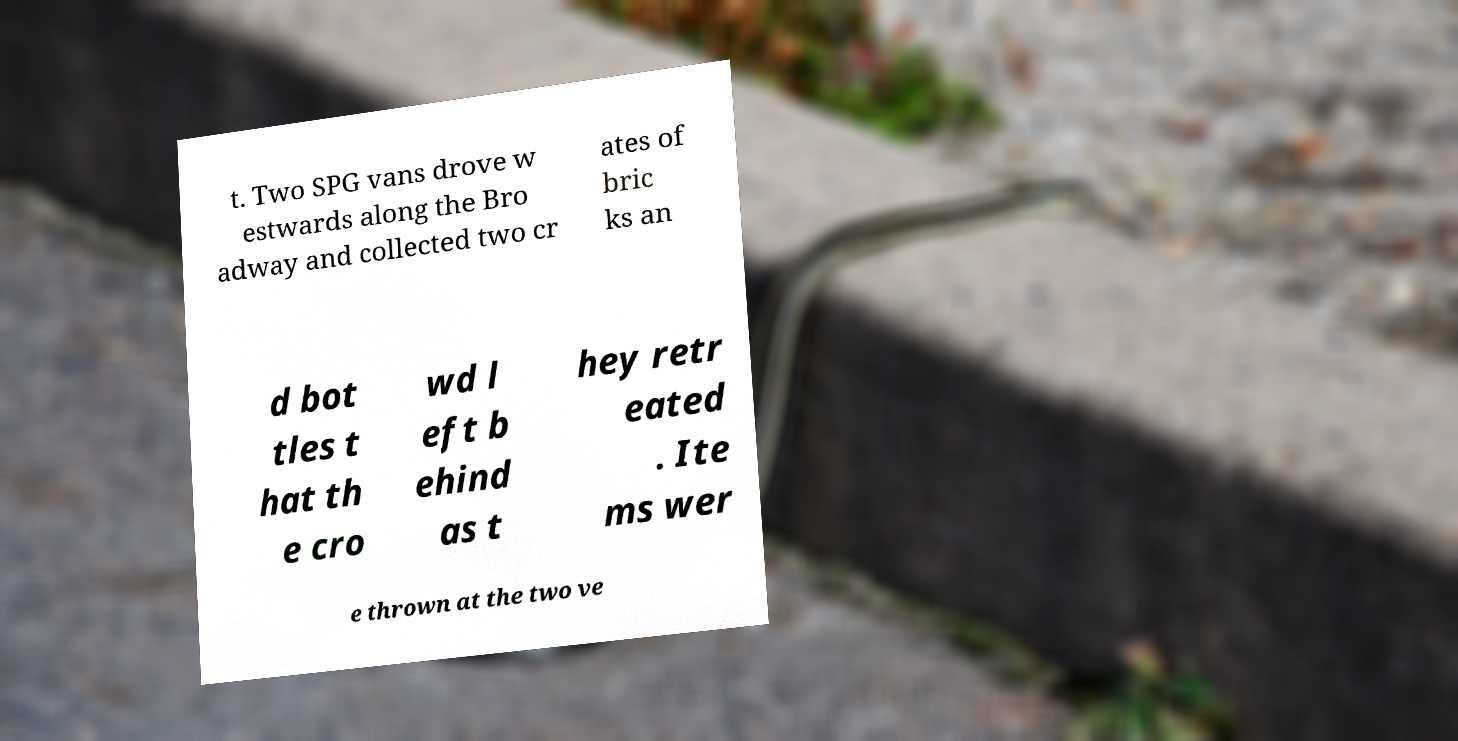What messages or text are displayed in this image? I need them in a readable, typed format. t. Two SPG vans drove w estwards along the Bro adway and collected two cr ates of bric ks an d bot tles t hat th e cro wd l eft b ehind as t hey retr eated . Ite ms wer e thrown at the two ve 